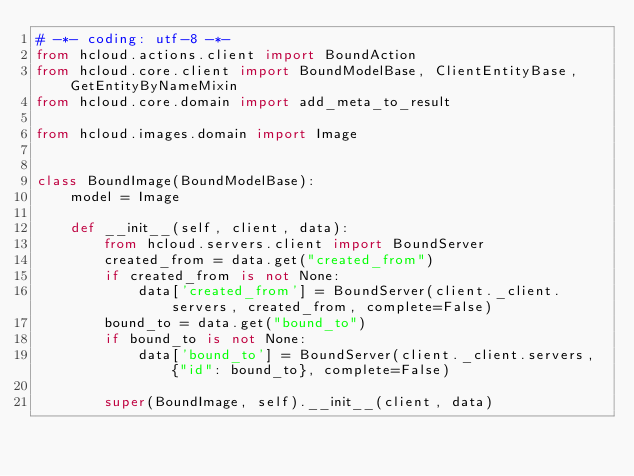Convert code to text. <code><loc_0><loc_0><loc_500><loc_500><_Python_># -*- coding: utf-8 -*-
from hcloud.actions.client import BoundAction
from hcloud.core.client import BoundModelBase, ClientEntityBase, GetEntityByNameMixin
from hcloud.core.domain import add_meta_to_result

from hcloud.images.domain import Image


class BoundImage(BoundModelBase):
    model = Image

    def __init__(self, client, data):
        from hcloud.servers.client import BoundServer
        created_from = data.get("created_from")
        if created_from is not None:
            data['created_from'] = BoundServer(client._client.servers, created_from, complete=False)
        bound_to = data.get("bound_to")
        if bound_to is not None:
            data['bound_to'] = BoundServer(client._client.servers, {"id": bound_to}, complete=False)

        super(BoundImage, self).__init__(client, data)
</code> 